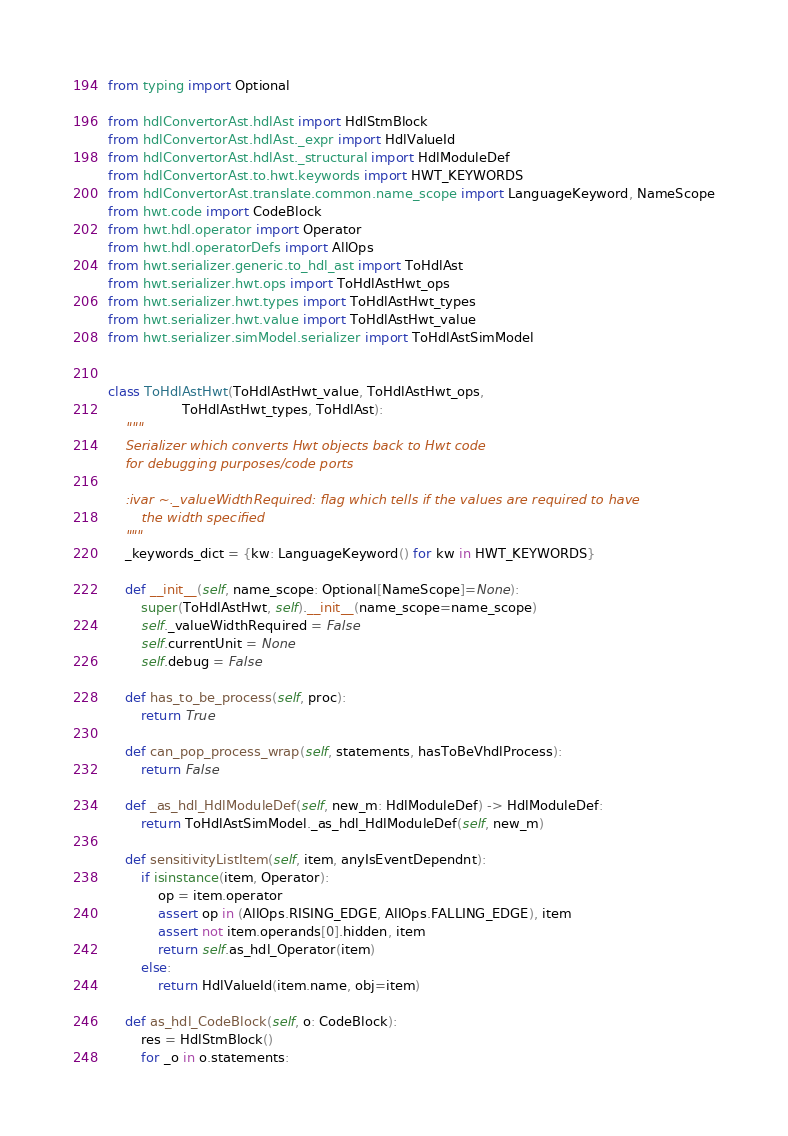Convert code to text. <code><loc_0><loc_0><loc_500><loc_500><_Python_>
from typing import Optional

from hdlConvertorAst.hdlAst import HdlStmBlock
from hdlConvertorAst.hdlAst._expr import HdlValueId
from hdlConvertorAst.hdlAst._structural import HdlModuleDef
from hdlConvertorAst.to.hwt.keywords import HWT_KEYWORDS
from hdlConvertorAst.translate.common.name_scope import LanguageKeyword, NameScope
from hwt.code import CodeBlock
from hwt.hdl.operator import Operator
from hwt.hdl.operatorDefs import AllOps
from hwt.serializer.generic.to_hdl_ast import ToHdlAst
from hwt.serializer.hwt.ops import ToHdlAstHwt_ops
from hwt.serializer.hwt.types import ToHdlAstHwt_types
from hwt.serializer.hwt.value import ToHdlAstHwt_value
from hwt.serializer.simModel.serializer import ToHdlAstSimModel


class ToHdlAstHwt(ToHdlAstHwt_value, ToHdlAstHwt_ops,
                  ToHdlAstHwt_types, ToHdlAst):
    """
    Serializer which converts Hwt objects back to Hwt code
    for debugging purposes/code ports

    :ivar ~._valueWidthRequired: flag which tells if the values are required to have
        the width specified
    """
    _keywords_dict = {kw: LanguageKeyword() for kw in HWT_KEYWORDS}

    def __init__(self, name_scope: Optional[NameScope]=None):
        super(ToHdlAstHwt, self).__init__(name_scope=name_scope)
        self._valueWidthRequired = False
        self.currentUnit = None
        self.debug = False

    def has_to_be_process(self, proc):
        return True

    def can_pop_process_wrap(self, statements, hasToBeVhdlProcess):
        return False

    def _as_hdl_HdlModuleDef(self, new_m: HdlModuleDef) -> HdlModuleDef:
        return ToHdlAstSimModel._as_hdl_HdlModuleDef(self, new_m)

    def sensitivityListItem(self, item, anyIsEventDependnt):
        if isinstance(item, Operator):
            op = item.operator
            assert op in (AllOps.RISING_EDGE, AllOps.FALLING_EDGE), item
            assert not item.operands[0].hidden, item
            return self.as_hdl_Operator(item)
        else:
            return HdlValueId(item.name, obj=item)

    def as_hdl_CodeBlock(self, o: CodeBlock):
        res = HdlStmBlock()
        for _o in o.statements:</code> 